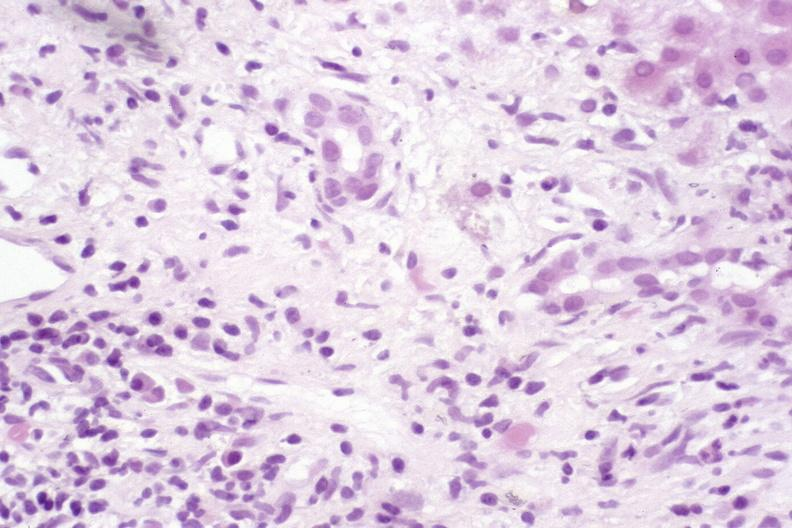does clostridial postmortem growth show primary sclerosing cholangitis?
Answer the question using a single word or phrase. No 